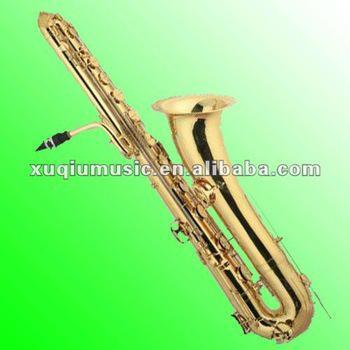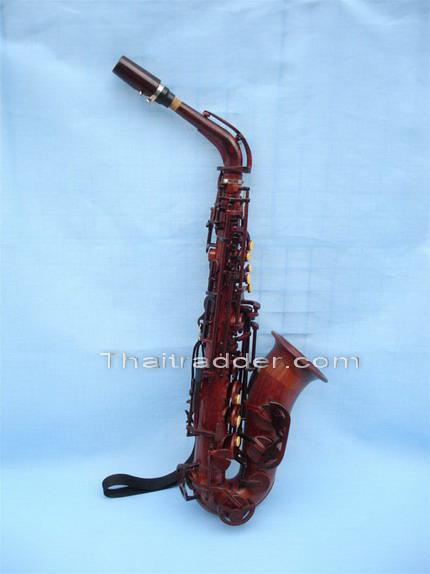The first image is the image on the left, the second image is the image on the right. Considering the images on both sides, is "There are at least three saxophones." valid? Answer yes or no. No. The first image is the image on the left, the second image is the image on the right. Examine the images to the left and right. Is the description "An image shows at least two wooden instruments displayed side-by-side." accurate? Answer yes or no. No. 